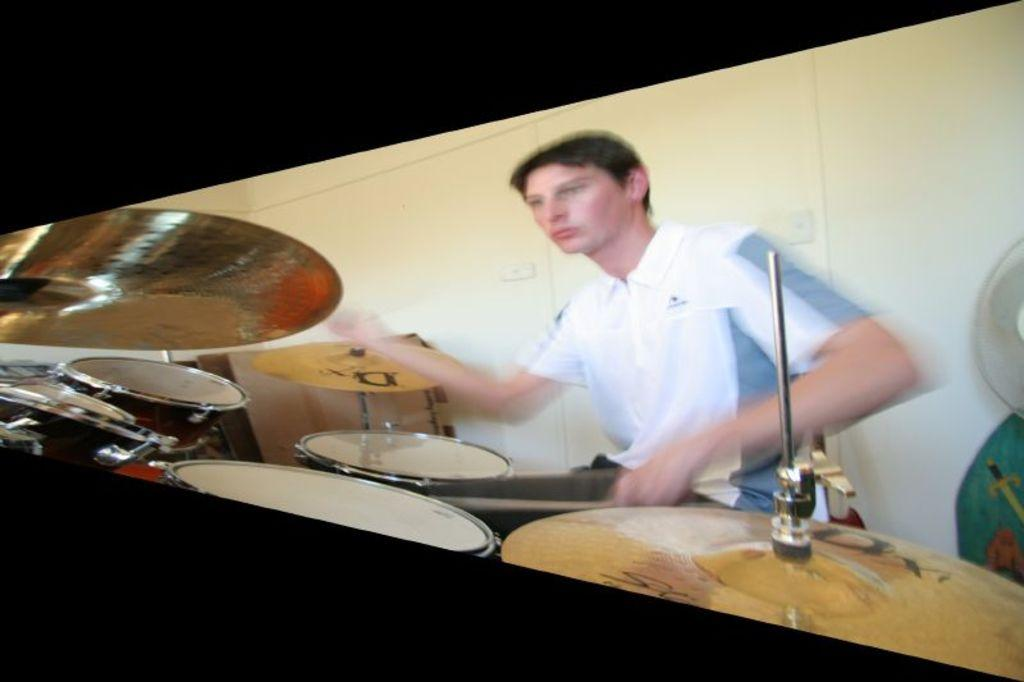What is the main subject of the image? There is a person in the image. What is the person doing in the image? The person is playing drums. What is the person wearing in the image? The person is wearing a white t-shirt. What type of silver cattle can be seen in the harbor in the image? There is no silver cattle or harbor present in the image; it features a person playing drums while wearing a white t-shirt. 